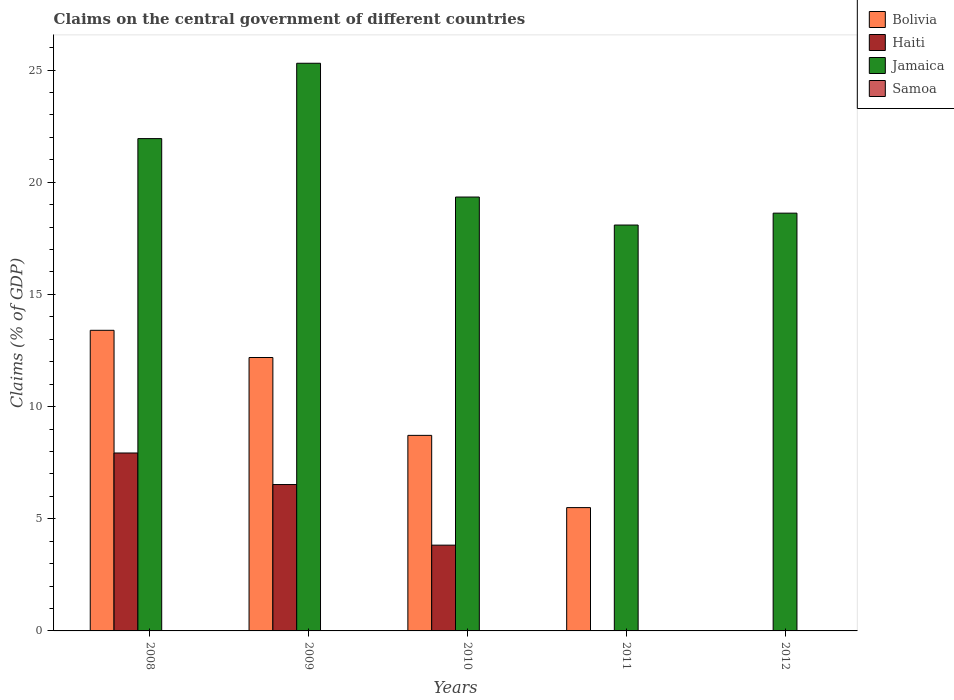How many different coloured bars are there?
Keep it short and to the point. 3. Are the number of bars on each tick of the X-axis equal?
Your response must be concise. No. How many bars are there on the 3rd tick from the right?
Provide a succinct answer. 3. In how many cases, is the number of bars for a given year not equal to the number of legend labels?
Offer a terse response. 5. What is the percentage of GDP claimed on the central government in Haiti in 2011?
Ensure brevity in your answer.  0. Across all years, what is the maximum percentage of GDP claimed on the central government in Haiti?
Your answer should be very brief. 7.93. In which year was the percentage of GDP claimed on the central government in Haiti maximum?
Ensure brevity in your answer.  2008. What is the total percentage of GDP claimed on the central government in Jamaica in the graph?
Your response must be concise. 103.3. What is the difference between the percentage of GDP claimed on the central government in Jamaica in 2009 and that in 2010?
Ensure brevity in your answer.  5.96. What is the difference between the percentage of GDP claimed on the central government in Bolivia in 2011 and the percentage of GDP claimed on the central government in Haiti in 2012?
Provide a short and direct response. 5.5. What is the average percentage of GDP claimed on the central government in Haiti per year?
Make the answer very short. 3.66. In the year 2008, what is the difference between the percentage of GDP claimed on the central government in Haiti and percentage of GDP claimed on the central government in Jamaica?
Offer a very short reply. -14.01. What is the ratio of the percentage of GDP claimed on the central government in Jamaica in 2009 to that in 2012?
Your answer should be very brief. 1.36. What is the difference between the highest and the second highest percentage of GDP claimed on the central government in Haiti?
Ensure brevity in your answer.  1.41. What is the difference between the highest and the lowest percentage of GDP claimed on the central government in Haiti?
Offer a terse response. 7.93. In how many years, is the percentage of GDP claimed on the central government in Samoa greater than the average percentage of GDP claimed on the central government in Samoa taken over all years?
Give a very brief answer. 0. Is the sum of the percentage of GDP claimed on the central government in Bolivia in 2009 and 2011 greater than the maximum percentage of GDP claimed on the central government in Jamaica across all years?
Keep it short and to the point. No. Is it the case that in every year, the sum of the percentage of GDP claimed on the central government in Bolivia and percentage of GDP claimed on the central government in Jamaica is greater than the sum of percentage of GDP claimed on the central government in Haiti and percentage of GDP claimed on the central government in Samoa?
Make the answer very short. No. How many years are there in the graph?
Your response must be concise. 5. What is the difference between two consecutive major ticks on the Y-axis?
Your answer should be compact. 5. Does the graph contain grids?
Provide a short and direct response. No. Where does the legend appear in the graph?
Ensure brevity in your answer.  Top right. How many legend labels are there?
Provide a short and direct response. 4. How are the legend labels stacked?
Keep it short and to the point. Vertical. What is the title of the graph?
Provide a short and direct response. Claims on the central government of different countries. Does "Tanzania" appear as one of the legend labels in the graph?
Give a very brief answer. No. What is the label or title of the X-axis?
Your answer should be compact. Years. What is the label or title of the Y-axis?
Make the answer very short. Claims (% of GDP). What is the Claims (% of GDP) in Bolivia in 2008?
Keep it short and to the point. 13.4. What is the Claims (% of GDP) in Haiti in 2008?
Ensure brevity in your answer.  7.93. What is the Claims (% of GDP) of Jamaica in 2008?
Your response must be concise. 21.94. What is the Claims (% of GDP) of Samoa in 2008?
Provide a short and direct response. 0. What is the Claims (% of GDP) of Bolivia in 2009?
Keep it short and to the point. 12.19. What is the Claims (% of GDP) in Haiti in 2009?
Your response must be concise. 6.53. What is the Claims (% of GDP) in Jamaica in 2009?
Make the answer very short. 25.3. What is the Claims (% of GDP) in Samoa in 2009?
Your answer should be very brief. 0. What is the Claims (% of GDP) of Bolivia in 2010?
Offer a very short reply. 8.72. What is the Claims (% of GDP) of Haiti in 2010?
Give a very brief answer. 3.82. What is the Claims (% of GDP) of Jamaica in 2010?
Provide a short and direct response. 19.34. What is the Claims (% of GDP) of Samoa in 2010?
Ensure brevity in your answer.  0. What is the Claims (% of GDP) in Bolivia in 2011?
Offer a very short reply. 5.5. What is the Claims (% of GDP) in Jamaica in 2011?
Make the answer very short. 18.09. What is the Claims (% of GDP) of Bolivia in 2012?
Keep it short and to the point. 0. What is the Claims (% of GDP) of Jamaica in 2012?
Keep it short and to the point. 18.62. What is the Claims (% of GDP) in Samoa in 2012?
Your answer should be very brief. 0. Across all years, what is the maximum Claims (% of GDP) of Bolivia?
Make the answer very short. 13.4. Across all years, what is the maximum Claims (% of GDP) of Haiti?
Make the answer very short. 7.93. Across all years, what is the maximum Claims (% of GDP) of Jamaica?
Offer a very short reply. 25.3. Across all years, what is the minimum Claims (% of GDP) of Haiti?
Offer a terse response. 0. Across all years, what is the minimum Claims (% of GDP) of Jamaica?
Provide a short and direct response. 18.09. What is the total Claims (% of GDP) in Bolivia in the graph?
Your answer should be very brief. 39.8. What is the total Claims (% of GDP) in Haiti in the graph?
Offer a terse response. 18.28. What is the total Claims (% of GDP) in Jamaica in the graph?
Your response must be concise. 103.3. What is the difference between the Claims (% of GDP) of Bolivia in 2008 and that in 2009?
Provide a short and direct response. 1.21. What is the difference between the Claims (% of GDP) in Haiti in 2008 and that in 2009?
Your answer should be compact. 1.41. What is the difference between the Claims (% of GDP) in Jamaica in 2008 and that in 2009?
Provide a succinct answer. -3.36. What is the difference between the Claims (% of GDP) in Bolivia in 2008 and that in 2010?
Keep it short and to the point. 4.68. What is the difference between the Claims (% of GDP) of Haiti in 2008 and that in 2010?
Offer a very short reply. 4.11. What is the difference between the Claims (% of GDP) of Jamaica in 2008 and that in 2010?
Offer a very short reply. 2.6. What is the difference between the Claims (% of GDP) of Bolivia in 2008 and that in 2011?
Offer a very short reply. 7.9. What is the difference between the Claims (% of GDP) of Jamaica in 2008 and that in 2011?
Your answer should be very brief. 3.85. What is the difference between the Claims (% of GDP) of Jamaica in 2008 and that in 2012?
Your answer should be compact. 3.32. What is the difference between the Claims (% of GDP) of Bolivia in 2009 and that in 2010?
Ensure brevity in your answer.  3.47. What is the difference between the Claims (% of GDP) of Haiti in 2009 and that in 2010?
Your response must be concise. 2.7. What is the difference between the Claims (% of GDP) of Jamaica in 2009 and that in 2010?
Your response must be concise. 5.96. What is the difference between the Claims (% of GDP) of Bolivia in 2009 and that in 2011?
Offer a terse response. 6.69. What is the difference between the Claims (% of GDP) in Jamaica in 2009 and that in 2011?
Give a very brief answer. 7.21. What is the difference between the Claims (% of GDP) of Jamaica in 2009 and that in 2012?
Give a very brief answer. 6.68. What is the difference between the Claims (% of GDP) of Bolivia in 2010 and that in 2011?
Provide a succinct answer. 3.22. What is the difference between the Claims (% of GDP) of Jamaica in 2010 and that in 2011?
Your answer should be very brief. 1.25. What is the difference between the Claims (% of GDP) of Jamaica in 2010 and that in 2012?
Ensure brevity in your answer.  0.72. What is the difference between the Claims (% of GDP) of Jamaica in 2011 and that in 2012?
Keep it short and to the point. -0.53. What is the difference between the Claims (% of GDP) in Bolivia in 2008 and the Claims (% of GDP) in Haiti in 2009?
Offer a very short reply. 6.87. What is the difference between the Claims (% of GDP) in Bolivia in 2008 and the Claims (% of GDP) in Jamaica in 2009?
Provide a succinct answer. -11.9. What is the difference between the Claims (% of GDP) of Haiti in 2008 and the Claims (% of GDP) of Jamaica in 2009?
Provide a short and direct response. -17.37. What is the difference between the Claims (% of GDP) of Bolivia in 2008 and the Claims (% of GDP) of Haiti in 2010?
Your response must be concise. 9.58. What is the difference between the Claims (% of GDP) of Bolivia in 2008 and the Claims (% of GDP) of Jamaica in 2010?
Ensure brevity in your answer.  -5.94. What is the difference between the Claims (% of GDP) in Haiti in 2008 and the Claims (% of GDP) in Jamaica in 2010?
Your answer should be compact. -11.41. What is the difference between the Claims (% of GDP) in Bolivia in 2008 and the Claims (% of GDP) in Jamaica in 2011?
Ensure brevity in your answer.  -4.69. What is the difference between the Claims (% of GDP) of Haiti in 2008 and the Claims (% of GDP) of Jamaica in 2011?
Your answer should be compact. -10.16. What is the difference between the Claims (% of GDP) of Bolivia in 2008 and the Claims (% of GDP) of Jamaica in 2012?
Your response must be concise. -5.22. What is the difference between the Claims (% of GDP) in Haiti in 2008 and the Claims (% of GDP) in Jamaica in 2012?
Offer a very short reply. -10.69. What is the difference between the Claims (% of GDP) of Bolivia in 2009 and the Claims (% of GDP) of Haiti in 2010?
Your answer should be compact. 8.36. What is the difference between the Claims (% of GDP) of Bolivia in 2009 and the Claims (% of GDP) of Jamaica in 2010?
Offer a terse response. -7.15. What is the difference between the Claims (% of GDP) in Haiti in 2009 and the Claims (% of GDP) in Jamaica in 2010?
Provide a short and direct response. -12.81. What is the difference between the Claims (% of GDP) of Bolivia in 2009 and the Claims (% of GDP) of Jamaica in 2011?
Make the answer very short. -5.9. What is the difference between the Claims (% of GDP) in Haiti in 2009 and the Claims (% of GDP) in Jamaica in 2011?
Your response must be concise. -11.57. What is the difference between the Claims (% of GDP) of Bolivia in 2009 and the Claims (% of GDP) of Jamaica in 2012?
Your response must be concise. -6.43. What is the difference between the Claims (% of GDP) of Haiti in 2009 and the Claims (% of GDP) of Jamaica in 2012?
Give a very brief answer. -12.1. What is the difference between the Claims (% of GDP) of Bolivia in 2010 and the Claims (% of GDP) of Jamaica in 2011?
Provide a succinct answer. -9.38. What is the difference between the Claims (% of GDP) in Haiti in 2010 and the Claims (% of GDP) in Jamaica in 2011?
Your answer should be compact. -14.27. What is the difference between the Claims (% of GDP) in Bolivia in 2010 and the Claims (% of GDP) in Jamaica in 2012?
Give a very brief answer. -9.9. What is the difference between the Claims (% of GDP) of Haiti in 2010 and the Claims (% of GDP) of Jamaica in 2012?
Provide a succinct answer. -14.8. What is the difference between the Claims (% of GDP) of Bolivia in 2011 and the Claims (% of GDP) of Jamaica in 2012?
Your response must be concise. -13.13. What is the average Claims (% of GDP) of Bolivia per year?
Provide a short and direct response. 7.96. What is the average Claims (% of GDP) of Haiti per year?
Keep it short and to the point. 3.66. What is the average Claims (% of GDP) in Jamaica per year?
Your answer should be very brief. 20.66. What is the average Claims (% of GDP) in Samoa per year?
Offer a very short reply. 0. In the year 2008, what is the difference between the Claims (% of GDP) of Bolivia and Claims (% of GDP) of Haiti?
Make the answer very short. 5.47. In the year 2008, what is the difference between the Claims (% of GDP) in Bolivia and Claims (% of GDP) in Jamaica?
Your answer should be compact. -8.54. In the year 2008, what is the difference between the Claims (% of GDP) in Haiti and Claims (% of GDP) in Jamaica?
Ensure brevity in your answer.  -14.01. In the year 2009, what is the difference between the Claims (% of GDP) in Bolivia and Claims (% of GDP) in Haiti?
Give a very brief answer. 5.66. In the year 2009, what is the difference between the Claims (% of GDP) of Bolivia and Claims (% of GDP) of Jamaica?
Ensure brevity in your answer.  -13.12. In the year 2009, what is the difference between the Claims (% of GDP) of Haiti and Claims (% of GDP) of Jamaica?
Your answer should be very brief. -18.78. In the year 2010, what is the difference between the Claims (% of GDP) in Bolivia and Claims (% of GDP) in Haiti?
Ensure brevity in your answer.  4.89. In the year 2010, what is the difference between the Claims (% of GDP) of Bolivia and Claims (% of GDP) of Jamaica?
Keep it short and to the point. -10.62. In the year 2010, what is the difference between the Claims (% of GDP) in Haiti and Claims (% of GDP) in Jamaica?
Your response must be concise. -15.52. In the year 2011, what is the difference between the Claims (% of GDP) of Bolivia and Claims (% of GDP) of Jamaica?
Make the answer very short. -12.6. What is the ratio of the Claims (% of GDP) of Bolivia in 2008 to that in 2009?
Provide a succinct answer. 1.1. What is the ratio of the Claims (% of GDP) in Haiti in 2008 to that in 2009?
Make the answer very short. 1.22. What is the ratio of the Claims (% of GDP) in Jamaica in 2008 to that in 2009?
Give a very brief answer. 0.87. What is the ratio of the Claims (% of GDP) in Bolivia in 2008 to that in 2010?
Give a very brief answer. 1.54. What is the ratio of the Claims (% of GDP) in Haiti in 2008 to that in 2010?
Offer a terse response. 2.07. What is the ratio of the Claims (% of GDP) in Jamaica in 2008 to that in 2010?
Your answer should be compact. 1.13. What is the ratio of the Claims (% of GDP) in Bolivia in 2008 to that in 2011?
Make the answer very short. 2.44. What is the ratio of the Claims (% of GDP) of Jamaica in 2008 to that in 2011?
Offer a terse response. 1.21. What is the ratio of the Claims (% of GDP) of Jamaica in 2008 to that in 2012?
Keep it short and to the point. 1.18. What is the ratio of the Claims (% of GDP) in Bolivia in 2009 to that in 2010?
Provide a succinct answer. 1.4. What is the ratio of the Claims (% of GDP) of Haiti in 2009 to that in 2010?
Keep it short and to the point. 1.71. What is the ratio of the Claims (% of GDP) in Jamaica in 2009 to that in 2010?
Keep it short and to the point. 1.31. What is the ratio of the Claims (% of GDP) of Bolivia in 2009 to that in 2011?
Keep it short and to the point. 2.22. What is the ratio of the Claims (% of GDP) in Jamaica in 2009 to that in 2011?
Provide a short and direct response. 1.4. What is the ratio of the Claims (% of GDP) in Jamaica in 2009 to that in 2012?
Provide a short and direct response. 1.36. What is the ratio of the Claims (% of GDP) of Bolivia in 2010 to that in 2011?
Offer a very short reply. 1.59. What is the ratio of the Claims (% of GDP) in Jamaica in 2010 to that in 2011?
Ensure brevity in your answer.  1.07. What is the ratio of the Claims (% of GDP) of Jamaica in 2010 to that in 2012?
Make the answer very short. 1.04. What is the ratio of the Claims (% of GDP) in Jamaica in 2011 to that in 2012?
Your answer should be compact. 0.97. What is the difference between the highest and the second highest Claims (% of GDP) of Bolivia?
Provide a succinct answer. 1.21. What is the difference between the highest and the second highest Claims (% of GDP) of Haiti?
Ensure brevity in your answer.  1.41. What is the difference between the highest and the second highest Claims (% of GDP) of Jamaica?
Your response must be concise. 3.36. What is the difference between the highest and the lowest Claims (% of GDP) in Bolivia?
Your answer should be compact. 13.4. What is the difference between the highest and the lowest Claims (% of GDP) of Haiti?
Provide a short and direct response. 7.93. What is the difference between the highest and the lowest Claims (% of GDP) in Jamaica?
Make the answer very short. 7.21. 